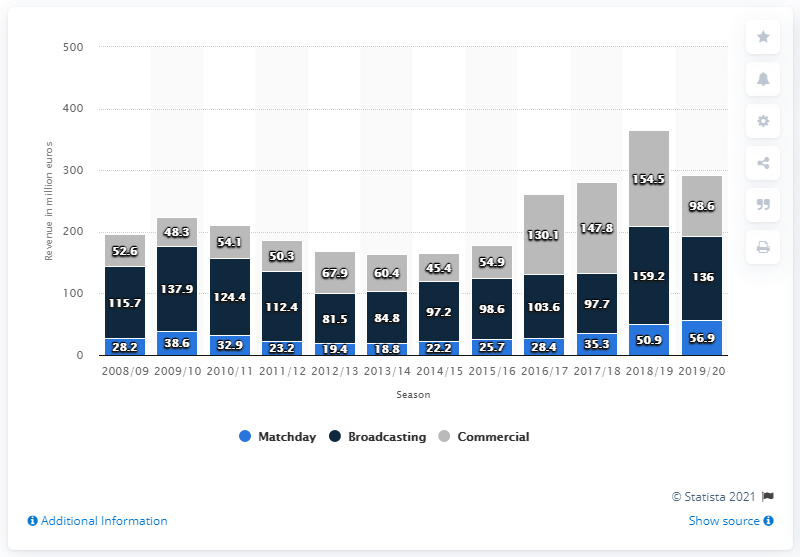Outline some significant characteristics in this image. In the 2019/2020 season, Internazionale Milano's broadcasting revenue was 136.. In the 2019/2020 season, Internazionale Milano earned a total of 98.6 million euros in sponsorship and merchandising revenue. 